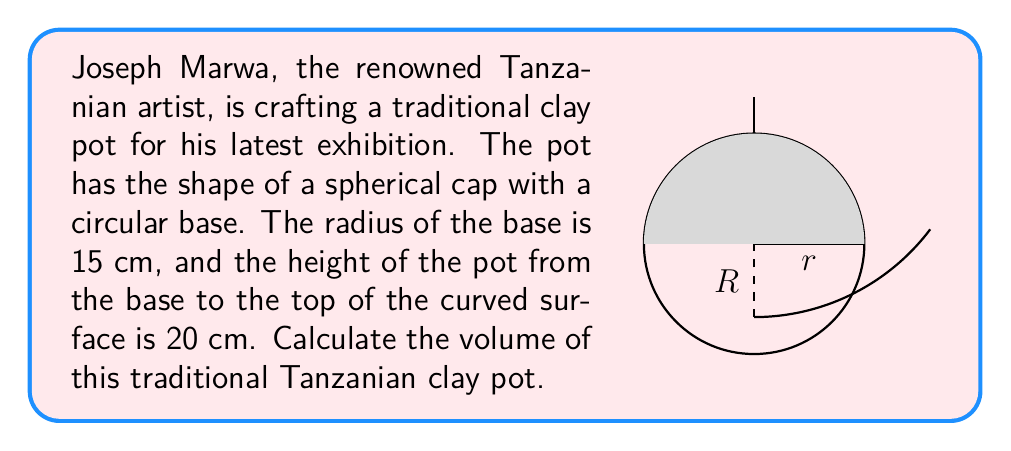Provide a solution to this math problem. To calculate the volume of the spherical cap-shaped pot, we'll follow these steps:

1) First, we need to find the radius (R) of the sphere from which the cap is cut. We can use the formula:

   $$R = \frac{r^2 + h^2}{2h}$$

   where r is the radius of the base and h is the height of the cap.

2) Substituting the given values:

   $$R = \frac{15^2 + 20^2}{2(20)} = \frac{225 + 400}{40} = \frac{625}{40} = 15.625 \text{ cm}$$

3) Now, we can use the formula for the volume of a spherical cap:

   $$V = \frac{1}{3}\pi h^2(3R - h)$$

4) Substituting our values:

   $$V = \frac{1}{3}\pi (20)^2(3(15.625) - 20)$$

5) Simplifying:

   $$V = \frac{1}{3}\pi (400)(46.875 - 20)$$
   $$V = \frac{1}{3}\pi (400)(26.875)$$
   $$V = \frac{400 \cdot 26.875}{3}\pi$$
   $$V = 3583.3333...\pi$$

6) Calculating the final result:

   $$V \approx 11,253.95 \text{ cm}^3$$
Answer: $11,253.95 \text{ cm}^3$ 